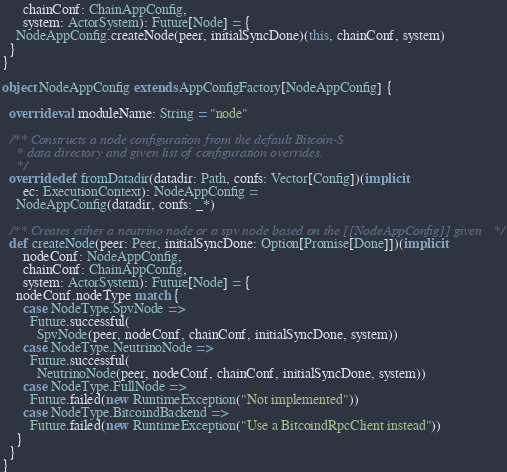<code> <loc_0><loc_0><loc_500><loc_500><_Scala_>      chainConf: ChainAppConfig,
      system: ActorSystem): Future[Node] = {
    NodeAppConfig.createNode(peer, initialSyncDone)(this, chainConf, system)
  }
}

object NodeAppConfig extends AppConfigFactory[NodeAppConfig] {

  override val moduleName: String = "node"

  /** Constructs a node configuration from the default Bitcoin-S
    * data directory and given list of configuration overrides.
    */
  override def fromDatadir(datadir: Path, confs: Vector[Config])(implicit
      ec: ExecutionContext): NodeAppConfig =
    NodeAppConfig(datadir, confs: _*)

  /** Creates either a neutrino node or a spv node based on the [[NodeAppConfig]] given */
  def createNode(peer: Peer, initialSyncDone: Option[Promise[Done]])(implicit
      nodeConf: NodeAppConfig,
      chainConf: ChainAppConfig,
      system: ActorSystem): Future[Node] = {
    nodeConf.nodeType match {
      case NodeType.SpvNode =>
        Future.successful(
          SpvNode(peer, nodeConf, chainConf, initialSyncDone, system))
      case NodeType.NeutrinoNode =>
        Future.successful(
          NeutrinoNode(peer, nodeConf, chainConf, initialSyncDone, system))
      case NodeType.FullNode =>
        Future.failed(new RuntimeException("Not implemented"))
      case NodeType.BitcoindBackend =>
        Future.failed(new RuntimeException("Use a BitcoindRpcClient instead"))
    }
  }
}
</code> 